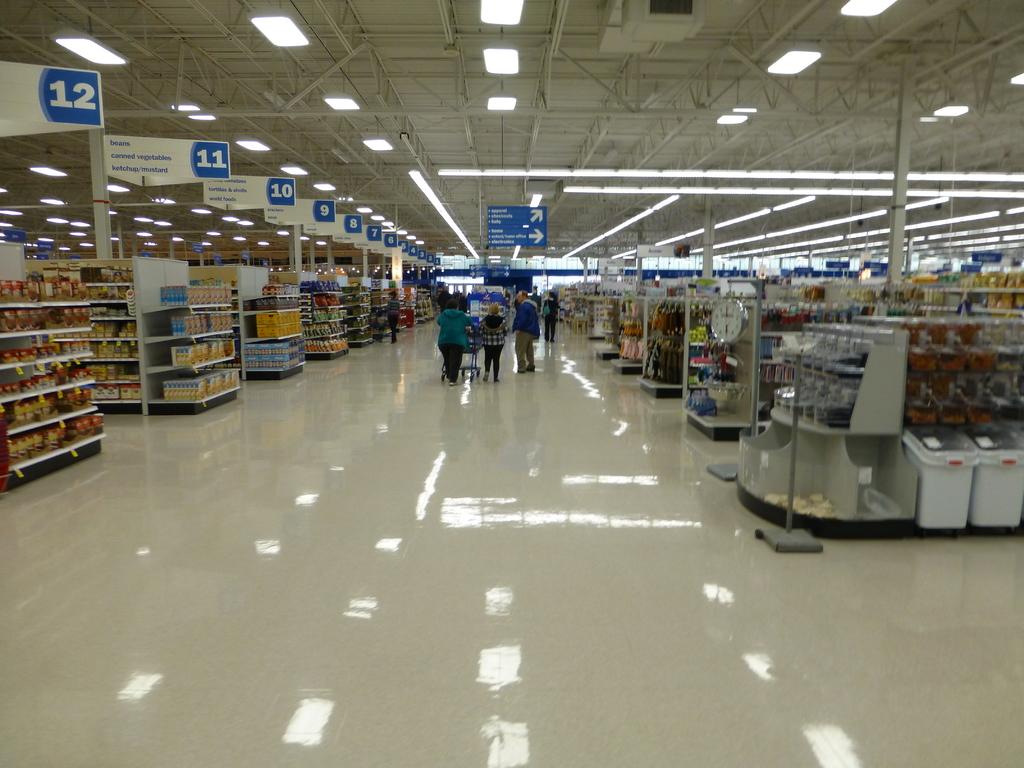What is the largest numbered aisle visible?
Offer a terse response. 12. 